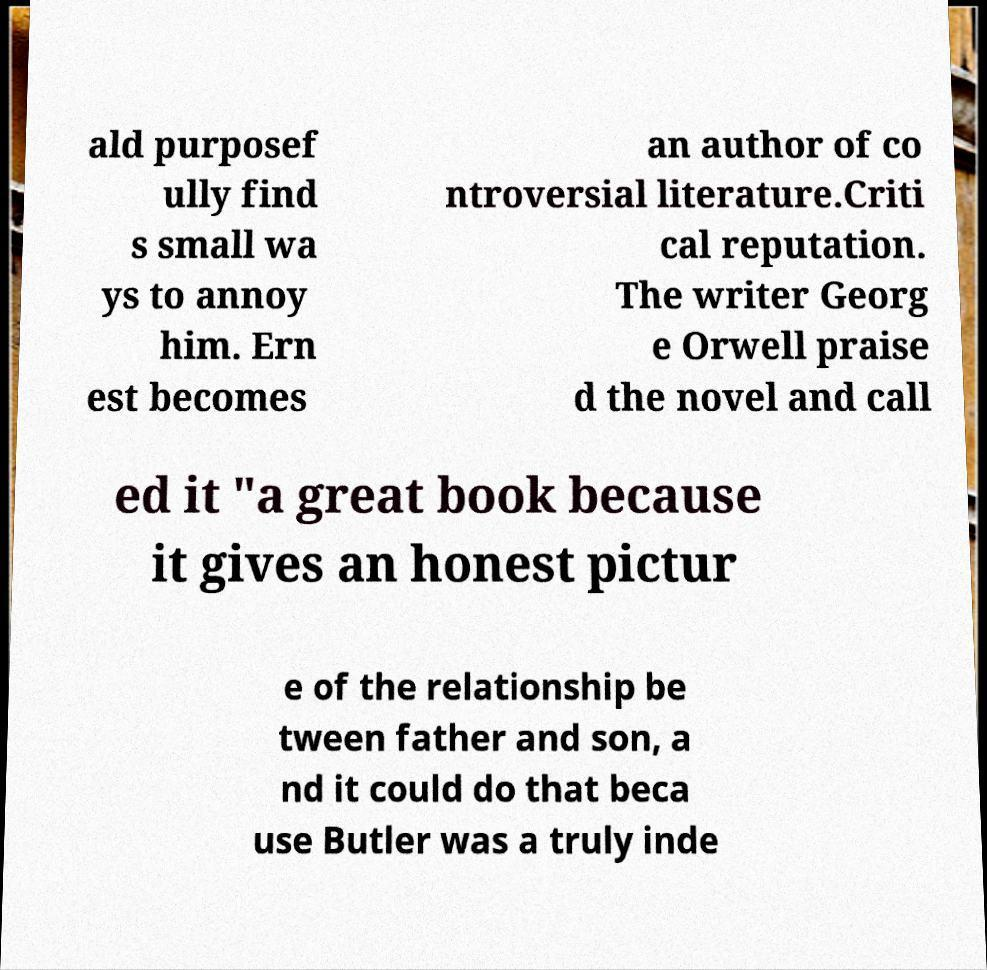I need the written content from this picture converted into text. Can you do that? ald purposef ully find s small wa ys to annoy him. Ern est becomes an author of co ntroversial literature.Criti cal reputation. The writer Georg e Orwell praise d the novel and call ed it "a great book because it gives an honest pictur e of the relationship be tween father and son, a nd it could do that beca use Butler was a truly inde 